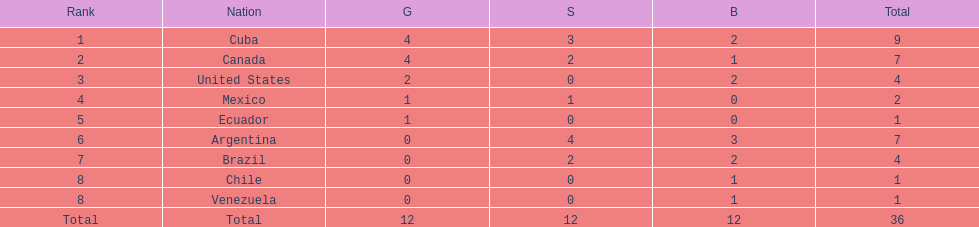Which nation won gold but did not win silver? United States. 